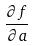<formula> <loc_0><loc_0><loc_500><loc_500>\frac { \partial f } { \partial a }</formula> 